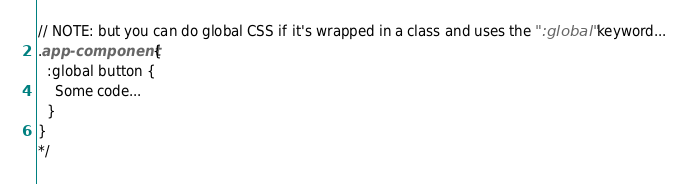Convert code to text. <code><loc_0><loc_0><loc_500><loc_500><_CSS_>// NOTE: but you can do global CSS if it's wrapped in a class and uses the ":global" keyword...
.app-component {
  :global button {
    Some code...
  }
}
*/</code> 